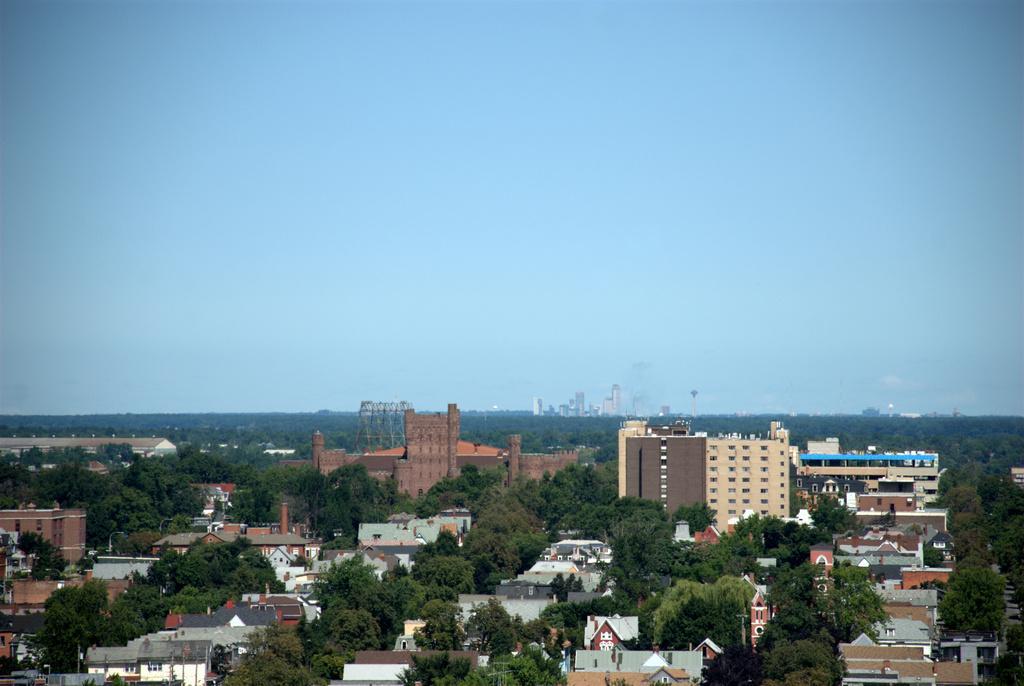Describe this image in one or two sentences. At the bottom of the picture, we see the buildings and trees. In the middle, we see the buildings and the towers. There are trees and the buildings in the background. At the top, we see the sky, which is blue in color. 